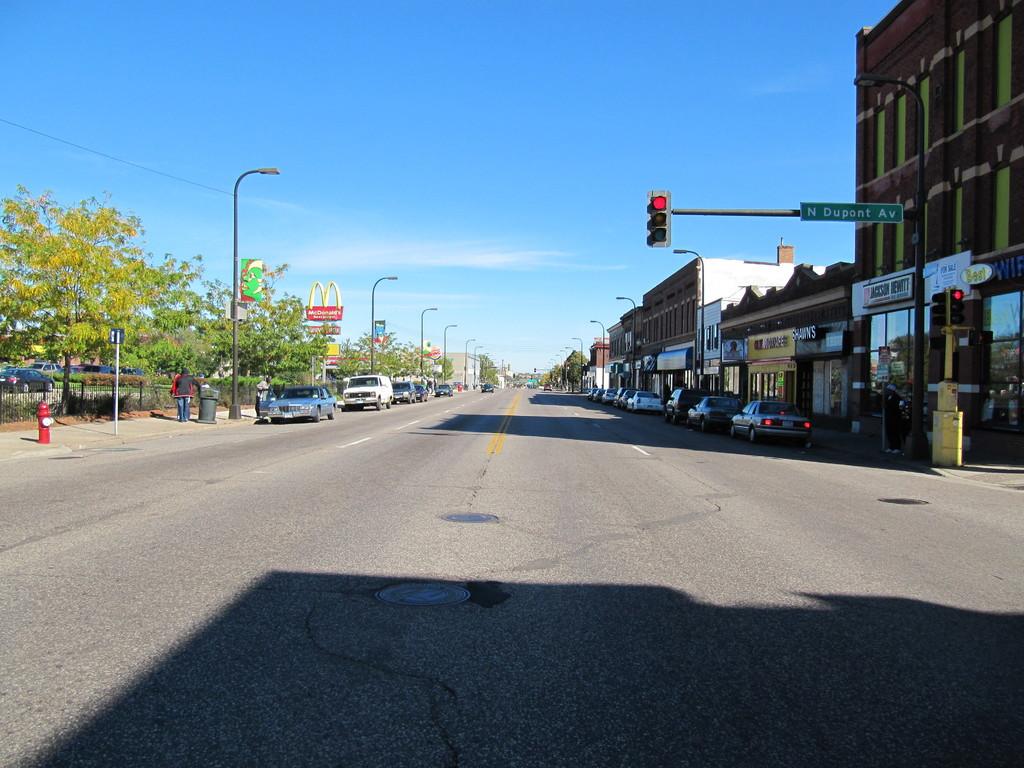What is the name of the street at the stop light?
Make the answer very short. N dupont ave. 